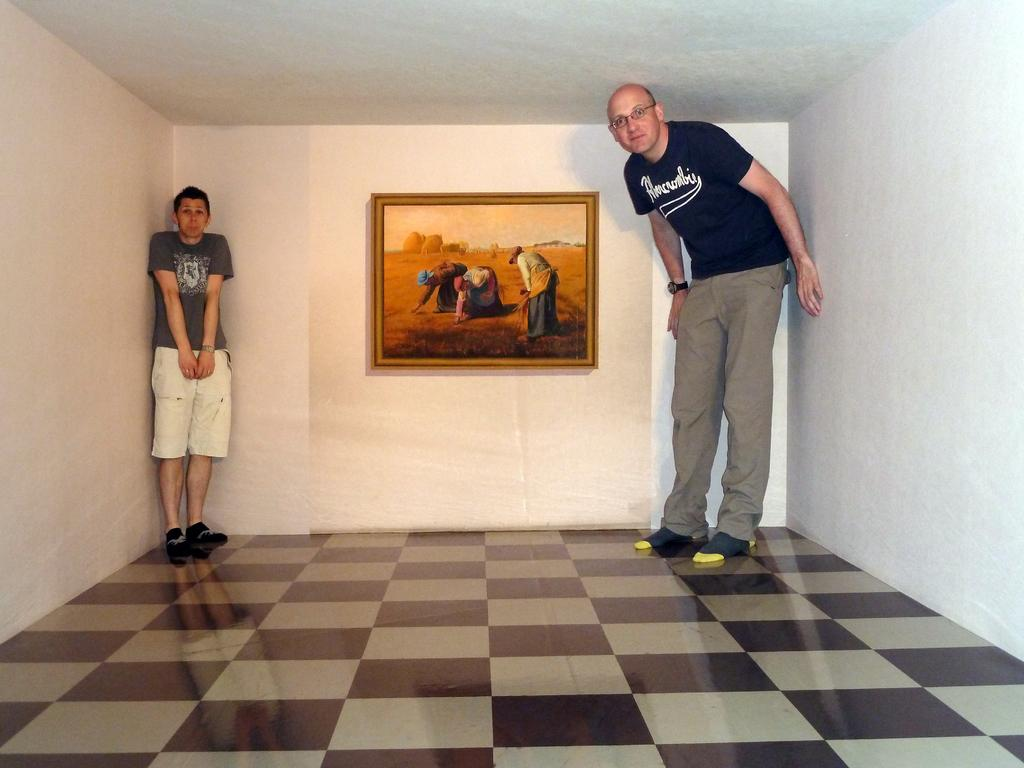How many people are in the image? There are two persons standing in the image. What can be seen in the background of the image? There is a wall in the background of the image. What is on the wall in the image? There is a portrait on the wall. What type of unit is being measured in the image? There is no unit being measured in the image; it features two persons standing near a wall with a portrait. How many halls are visible in the image? There are no halls visible in the image; it features two persons standing near a wall with a portrait. 